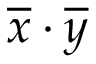Convert formula to latex. <formula><loc_0><loc_0><loc_500><loc_500>{ \overline { x } } \cdot { \overline { y } }</formula> 